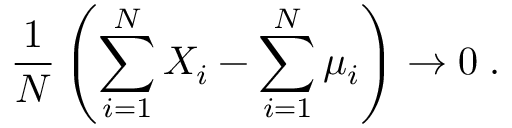Convert formula to latex. <formula><loc_0><loc_0><loc_500><loc_500>\frac { 1 } { N } \left ( \sum _ { i = 1 } ^ { N } X _ { i } - \sum _ { i = 1 } ^ { N } \mu _ { i } \right ) \to 0 \, .</formula> 